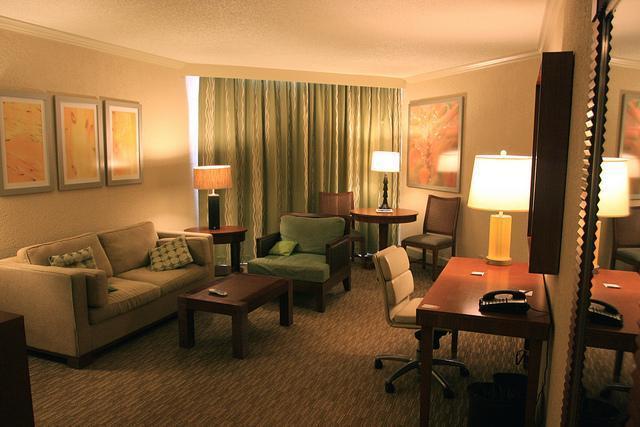How many chairs can you see?
Give a very brief answer. 3. How many couches can be seen?
Give a very brief answer. 1. How many people are crouching down?
Give a very brief answer. 0. 